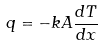<formula> <loc_0><loc_0><loc_500><loc_500>q = - k A \frac { d T } { d x }</formula> 